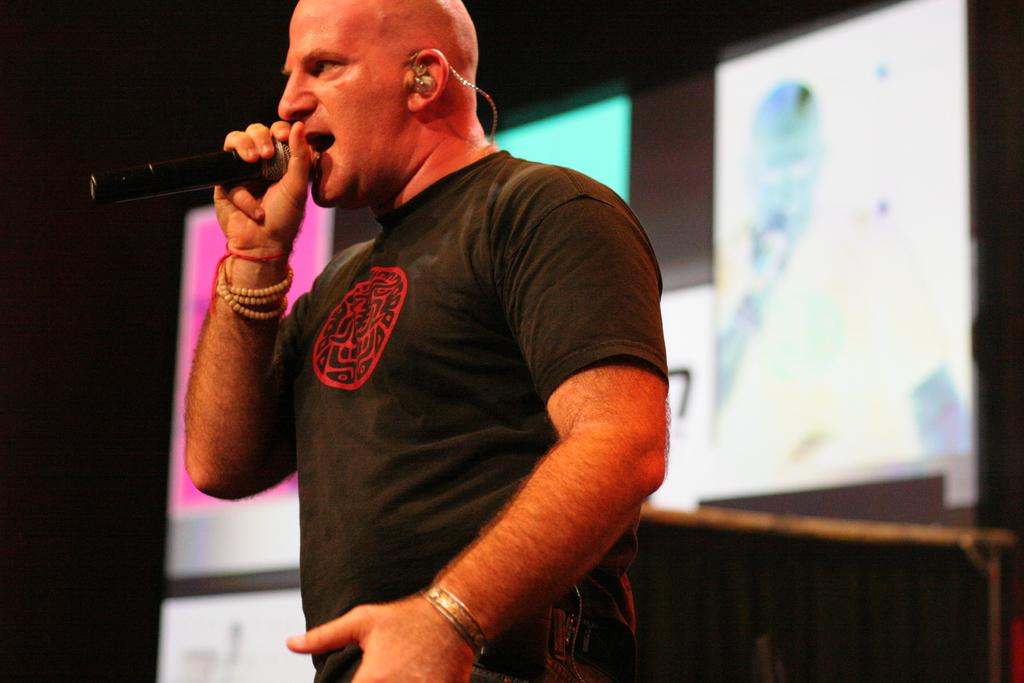What is the main subject of the image? The main subject of the image is a man standing in the middle. What is the man holding in the image? The man is holding a microphone. What is the man doing in the image? The man is speaking. What can be seen behind the man in the image? There is a screen behind the man. What type of sea can be seen in the background of the image? There is no sea visible in the image; it features a man standing with a microphone and a screen in the background. 